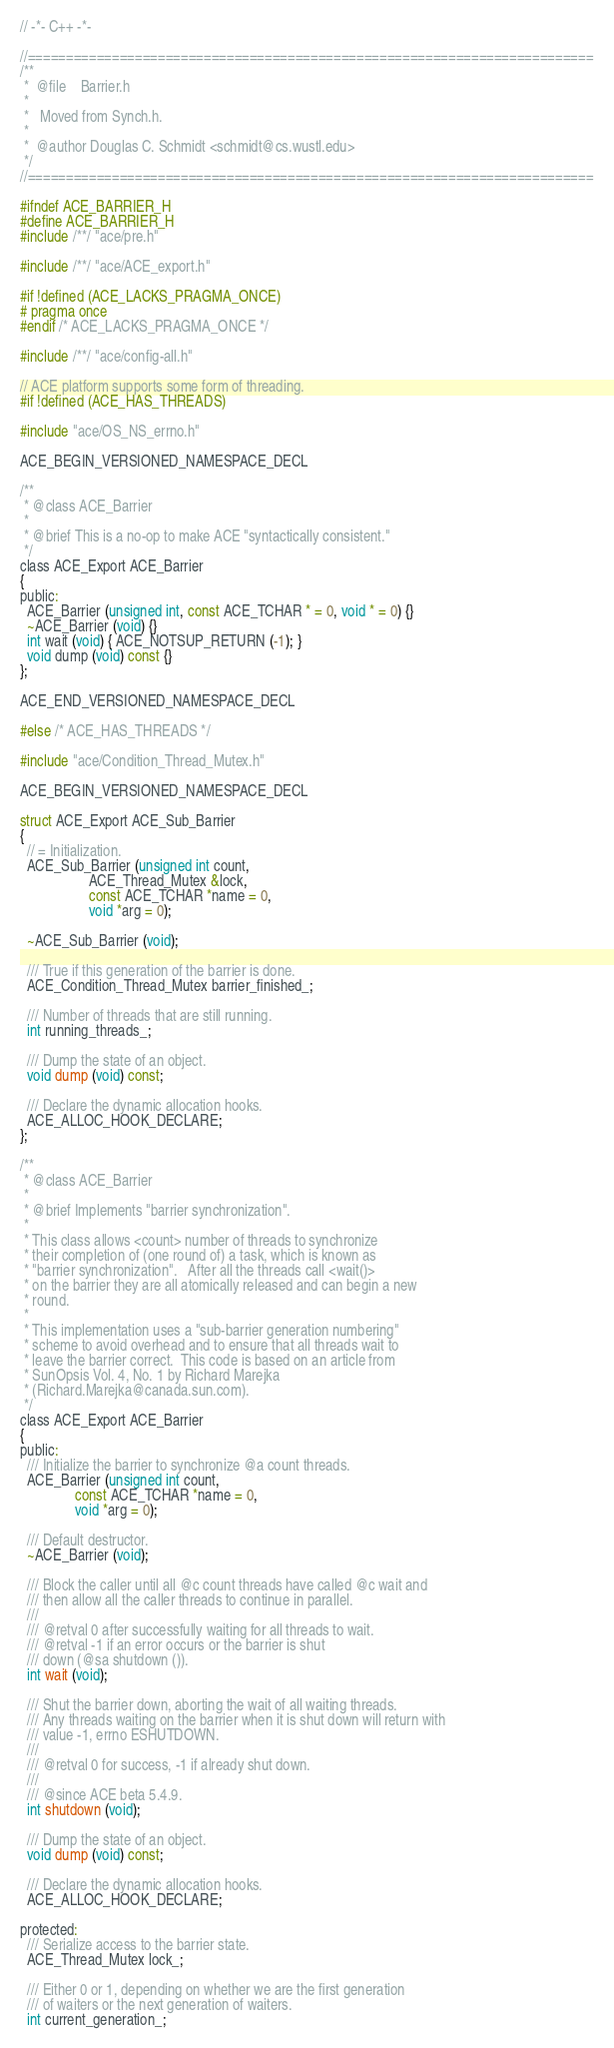Convert code to text. <code><loc_0><loc_0><loc_500><loc_500><_C_>// -*- C++ -*-

//==========================================================================
/**
 *  @file    Barrier.h
 *
 *   Moved from Synch.h.
 *
 *  @author Douglas C. Schmidt <schmidt@cs.wustl.edu>
 */
//==========================================================================

#ifndef ACE_BARRIER_H
#define ACE_BARRIER_H
#include /**/ "ace/pre.h"

#include /**/ "ace/ACE_export.h"

#if !defined (ACE_LACKS_PRAGMA_ONCE)
# pragma once
#endif /* ACE_LACKS_PRAGMA_ONCE */

#include /**/ "ace/config-all.h"

// ACE platform supports some form of threading.
#if !defined (ACE_HAS_THREADS)

#include "ace/OS_NS_errno.h"

ACE_BEGIN_VERSIONED_NAMESPACE_DECL

/**
 * @class ACE_Barrier
 *
 * @brief This is a no-op to make ACE "syntactically consistent."
 */
class ACE_Export ACE_Barrier
{
public:
  ACE_Barrier (unsigned int, const ACE_TCHAR * = 0, void * = 0) {}
  ~ACE_Barrier (void) {}
  int wait (void) { ACE_NOTSUP_RETURN (-1); }
  void dump (void) const {}
};

ACE_END_VERSIONED_NAMESPACE_DECL

#else /* ACE_HAS_THREADS */

#include "ace/Condition_Thread_Mutex.h"

ACE_BEGIN_VERSIONED_NAMESPACE_DECL

struct ACE_Export ACE_Sub_Barrier
{
  // = Initialization.
  ACE_Sub_Barrier (unsigned int count,
                   ACE_Thread_Mutex &lock,
                   const ACE_TCHAR *name = 0,
                   void *arg = 0);

  ~ACE_Sub_Barrier (void);

  /// True if this generation of the barrier is done.
  ACE_Condition_Thread_Mutex barrier_finished_;

  /// Number of threads that are still running.
  int running_threads_;

  /// Dump the state of an object.
  void dump (void) const;

  /// Declare the dynamic allocation hooks.
  ACE_ALLOC_HOOK_DECLARE;
};

/**
 * @class ACE_Barrier
 *
 * @brief Implements "barrier synchronization".
 *
 * This class allows <count> number of threads to synchronize
 * their completion of (one round of) a task, which is known as
 * "barrier synchronization".   After all the threads call <wait()>
 * on the barrier they are all atomically released and can begin a new
 * round.
 *
 * This implementation uses a "sub-barrier generation numbering"
 * scheme to avoid overhead and to ensure that all threads wait to
 * leave the barrier correct.  This code is based on an article from
 * SunOpsis Vol. 4, No. 1 by Richard Marejka
 * (Richard.Marejka@canada.sun.com).
 */
class ACE_Export ACE_Barrier
{
public:
  /// Initialize the barrier to synchronize @a count threads.
  ACE_Barrier (unsigned int count,
               const ACE_TCHAR *name = 0,
               void *arg = 0);

  /// Default destructor.
  ~ACE_Barrier (void);

  /// Block the caller until all @c count threads have called @c wait and
  /// then allow all the caller threads to continue in parallel.
  ///
  /// @retval 0 after successfully waiting for all threads to wait.
  /// @retval -1 if an error occurs or the barrier is shut
  /// down (@sa shutdown ()).
  int wait (void);

  /// Shut the barrier down, aborting the wait of all waiting threads.
  /// Any threads waiting on the barrier when it is shut down will return with
  /// value -1, errno ESHUTDOWN.
  ///
  /// @retval 0 for success, -1 if already shut down.
  ///
  /// @since ACE beta 5.4.9.
  int shutdown (void);

  /// Dump the state of an object.
  void dump (void) const;

  /// Declare the dynamic allocation hooks.
  ACE_ALLOC_HOOK_DECLARE;

protected:
  /// Serialize access to the barrier state.
  ACE_Thread_Mutex lock_;

  /// Either 0 or 1, depending on whether we are the first generation
  /// of waiters or the next generation of waiters.
  int current_generation_;
</code> 